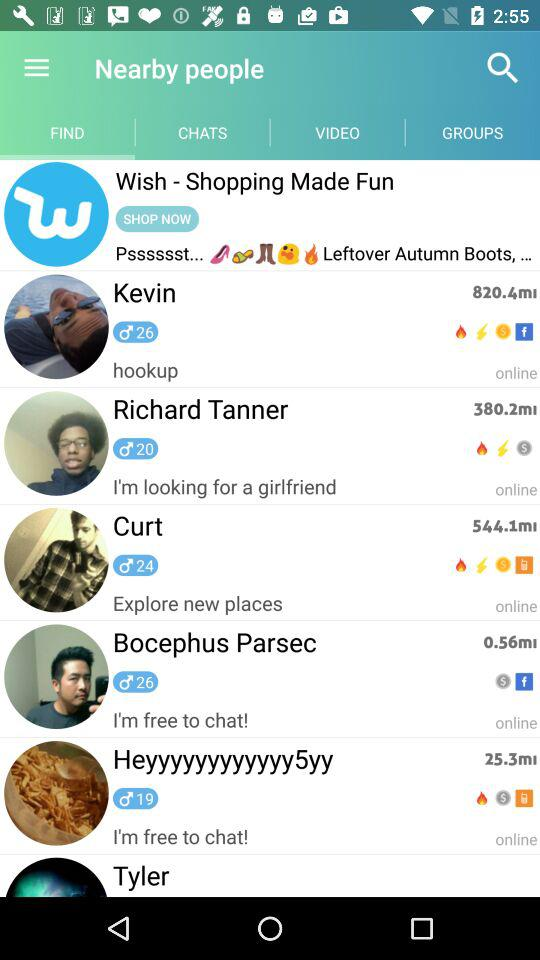What is the distance between Kevin and my place? The distance is 820.4 ml. 